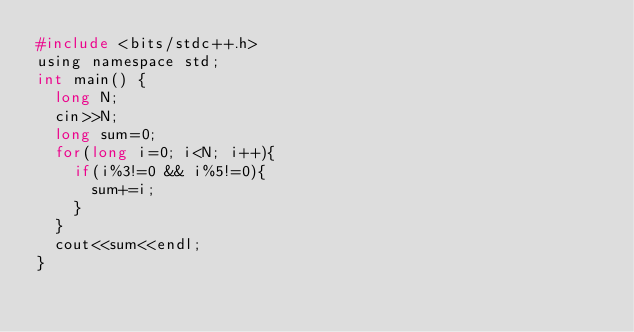<code> <loc_0><loc_0><loc_500><loc_500><_C_>#include <bits/stdc++.h>
using namespace std;
int main() {
  long N;
  cin>>N;
  long sum=0;
  for(long i=0; i<N; i++){
    if(i%3!=0 && i%5!=0){
      sum+=i;
    }
  }
  cout<<sum<<endl;
}
</code> 